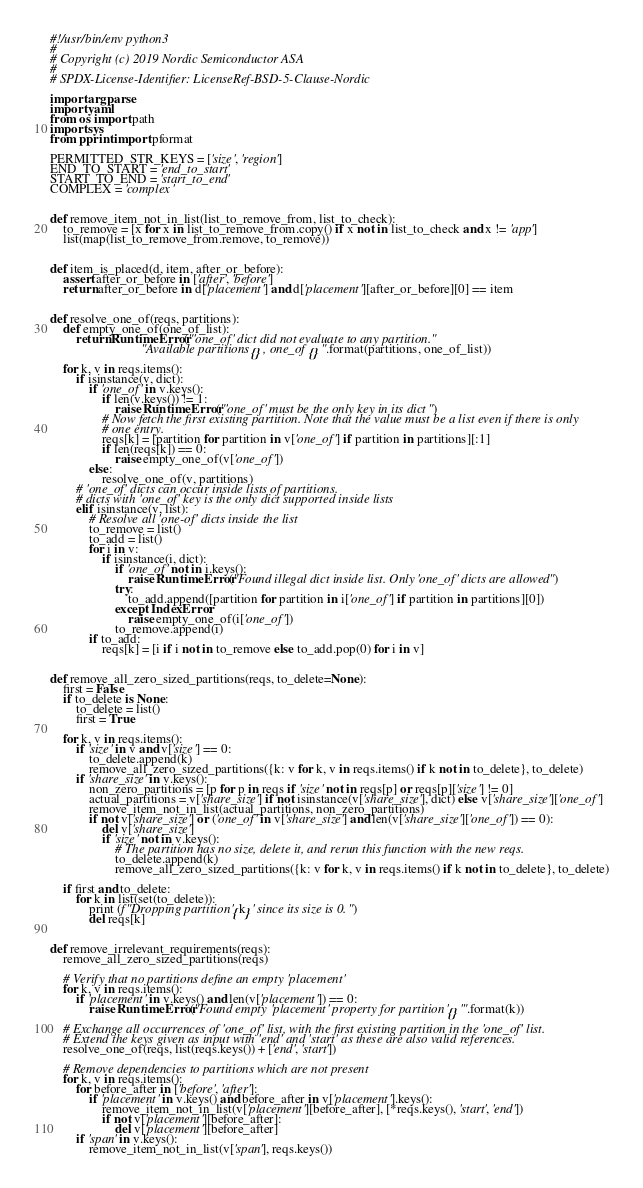Convert code to text. <code><loc_0><loc_0><loc_500><loc_500><_Python_>#!/usr/bin/env python3
#
# Copyright (c) 2019 Nordic Semiconductor ASA
#
# SPDX-License-Identifier: LicenseRef-BSD-5-Clause-Nordic

import argparse
import yaml
from os import path
import sys
from pprint import pformat

PERMITTED_STR_KEYS = ['size', 'region']
END_TO_START = 'end_to_start'
START_TO_END = 'start_to_end'
COMPLEX = 'complex'


def remove_item_not_in_list(list_to_remove_from, list_to_check):
    to_remove = [x for x in list_to_remove_from.copy() if x not in list_to_check and x != 'app']
    list(map(list_to_remove_from.remove, to_remove))


def item_is_placed(d, item, after_or_before):
    assert after_or_before in ['after', 'before']
    return after_or_before in d['placement'] and d['placement'][after_or_before][0] == item


def resolve_one_of(reqs, partitions):
    def empty_one_of(one_of_list):
        return RuntimeError("'one_of' dict did not evaluate to any partition. "
                            "Available partitions {}, one_of {}".format(partitions, one_of_list))

    for k, v in reqs.items():
        if isinstance(v, dict):
            if 'one_of' in v.keys():
                if len(v.keys()) != 1:
                    raise RuntimeError("'one_of' must be the only key in its dict")
                # Now fetch the first existing partition. Note that the value must be a list even if there is only
                # one entry.
                reqs[k] = [partition for partition in v['one_of'] if partition in partitions][:1]
                if len(reqs[k]) == 0:
                    raise empty_one_of(v['one_of'])
            else:
                resolve_one_of(v, partitions)
        # 'one_of' dicts can occur inside lists of partitions.
        # dicts with 'one_of' key is the only dict supported inside lists
        elif isinstance(v, list):
            # Resolve all 'one-of' dicts inside the list
            to_remove = list()
            to_add = list()
            for i in v:
                if isinstance(i, dict):
                    if 'one_of' not in i.keys():
                        raise RuntimeError("Found illegal dict inside list. Only 'one_of' dicts are allowed")
                    try:
                        to_add.append([partition for partition in i['one_of'] if partition in partitions][0])
                    except IndexError:
                        raise empty_one_of(i['one_of'])
                    to_remove.append(i)
            if to_add:
                reqs[k] = [i if i not in to_remove else to_add.pop(0) for i in v]


def remove_all_zero_sized_partitions(reqs, to_delete=None):
    first = False
    if to_delete is None:
        to_delete = list()
        first = True

    for k, v in reqs.items():
        if 'size' in v and v['size'] == 0:
            to_delete.append(k)
            remove_all_zero_sized_partitions({k: v for k, v in reqs.items() if k not in to_delete}, to_delete)
        if 'share_size' in v.keys():
            non_zero_partitions = [p for p in reqs if 'size' not in reqs[p] or reqs[p]['size'] != 0]
            actual_partitions = v['share_size'] if not isinstance(v['share_size'], dict) else v['share_size']['one_of']
            remove_item_not_in_list(actual_partitions, non_zero_partitions)
            if not v['share_size'] or ('one_of' in v['share_size'] and len(v['share_size']['one_of']) == 0):
                del v['share_size']
                if 'size' not in v.keys():
                    # The partition has no size, delete it, and rerun this function with the new reqs.
                    to_delete.append(k)
                    remove_all_zero_sized_partitions({k: v for k, v in reqs.items() if k not in to_delete}, to_delete)

    if first and to_delete:
        for k in list(set(to_delete)):
            print (f"Dropping partition '{k}' since its size is 0.")
            del reqs[k]


def remove_irrelevant_requirements(reqs):
    remove_all_zero_sized_partitions(reqs)

    # Verify that no partitions define an empty 'placement'
    for k, v in reqs.items():
        if 'placement' in v.keys() and len(v['placement']) == 0:
            raise RuntimeError("Found empty 'placement' property for partition '{}'".format(k))

    # Exchange all occurrences of 'one_of' list, with the first existing partition in the 'one_of' list.
    # Extend the keys given as input with 'end' and 'start' as these are also valid references.
    resolve_one_of(reqs, list(reqs.keys()) + ['end', 'start'])

    # Remove dependencies to partitions which are not present
    for k, v in reqs.items():
        for before_after in ['before', 'after']:
            if 'placement' in v.keys() and before_after in v['placement'].keys():
                remove_item_not_in_list(v['placement'][before_after], [*reqs.keys(), 'start', 'end'])
                if not v['placement'][before_after]:
                    del v['placement'][before_after]
        if 'span' in v.keys():
            remove_item_not_in_list(v['span'], reqs.keys())</code> 